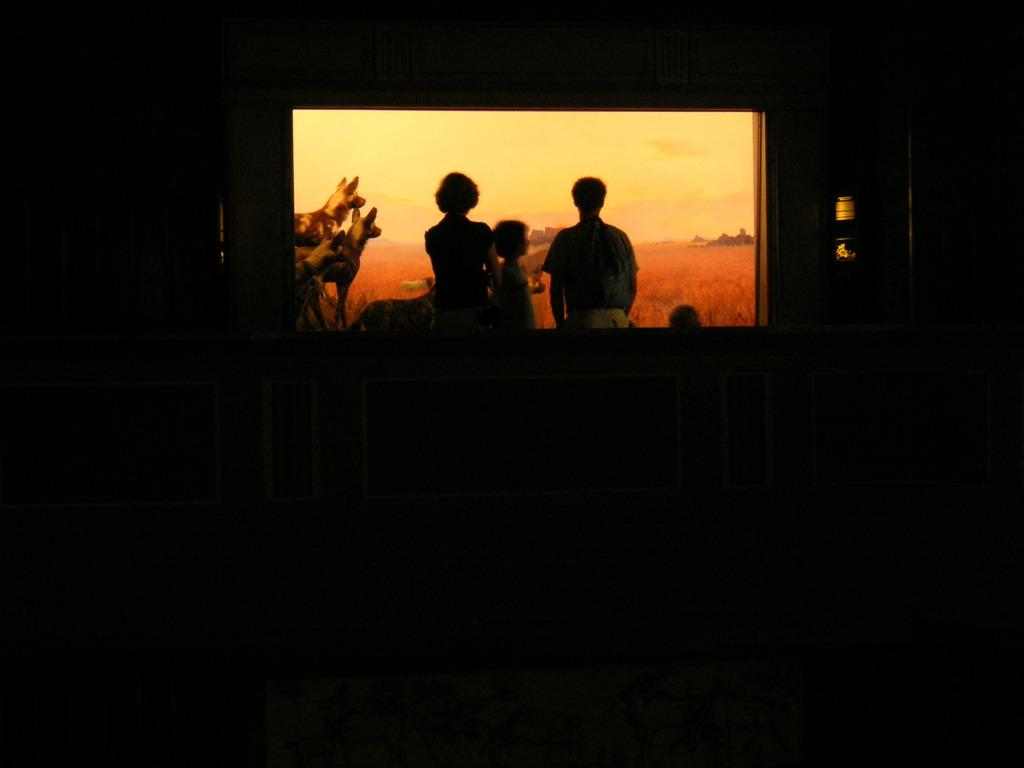What is the main object in the picture that is displaying images? There is a screen displaying images in the picture. What types of subjects can be seen on the screen? The images on the screen include people and animals. How would you describe the lighting conditions in the picture? The surroundings in the picture appear dark. Can you tell me how many parcels are visible on the screen? There is no mention of parcels in the image; the screen displays images of people and animals. What type of roll is being used to create the images on the screen? There is no roll or any other tool visible in the image; the screen is displaying pre-existing images. 